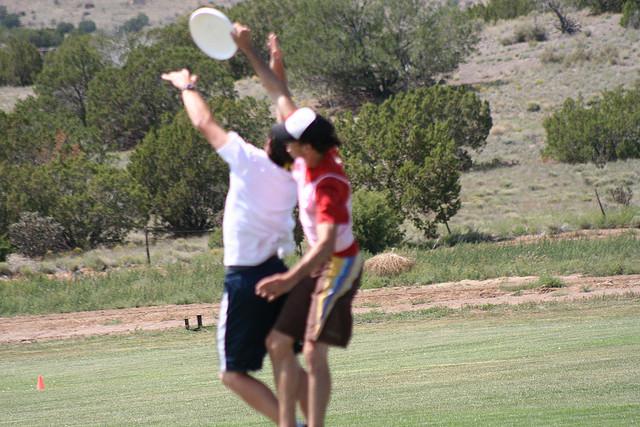Are they playing Frisbee?
Keep it brief. Yes. What is the guy catching?
Be succinct. Frisbee. What are the two men standing on?
Give a very brief answer. Grass. 